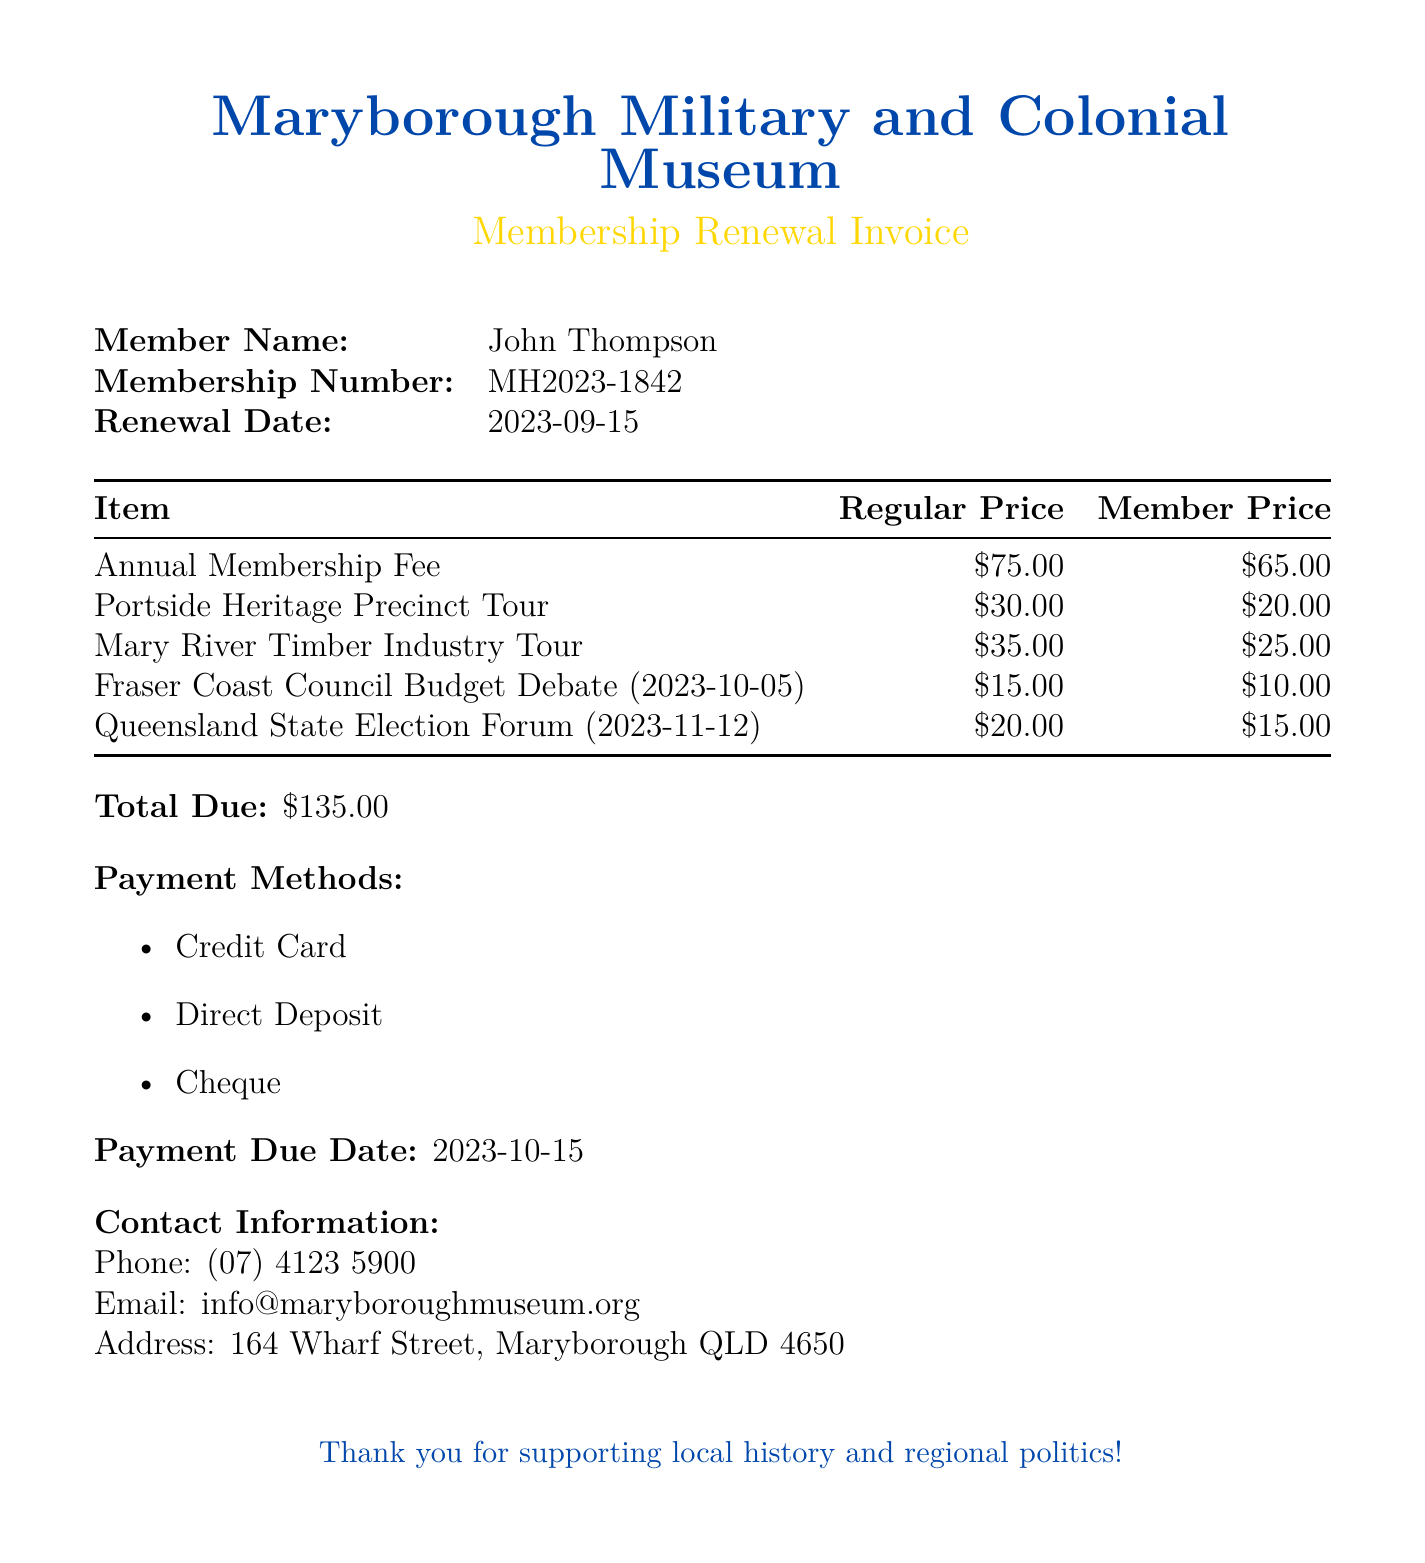What is the member name? The document states the member name as John Thompson.
Answer: John Thompson What is the membership number? The membership number is provided in the document, which is MH2023-1842.
Answer: MH2023-1842 What is the total due amount? The total due amount is clearly listed in the document as $135.00.
Answer: $135.00 What discount is offered for the Portside Heritage Precinct Tour? The member price for this tour is provided, indicating a discount from the regular price.
Answer: $20.00 When is the payment due date? The payment due date is mentioned in the document, which is 2023-10-15.
Answer: 2023-10-15 What event is scheduled for 2023-10-05? The document lists the Fraser Coast Council Budget Debate on that specific date.
Answer: Fraser Coast Council Budget Debate How much is the annual membership fee for members? The document specifies the member price for the annual membership fee.
Answer: $65.00 What is the regular price for the Queensland State Election Forum? The document provides the regular price for this event directly.
Answer: $20.00 What type of organization is the Maryborough Military and Colonial Museum? The document indicates that it is related to local history and regional politics.
Answer: Museum 